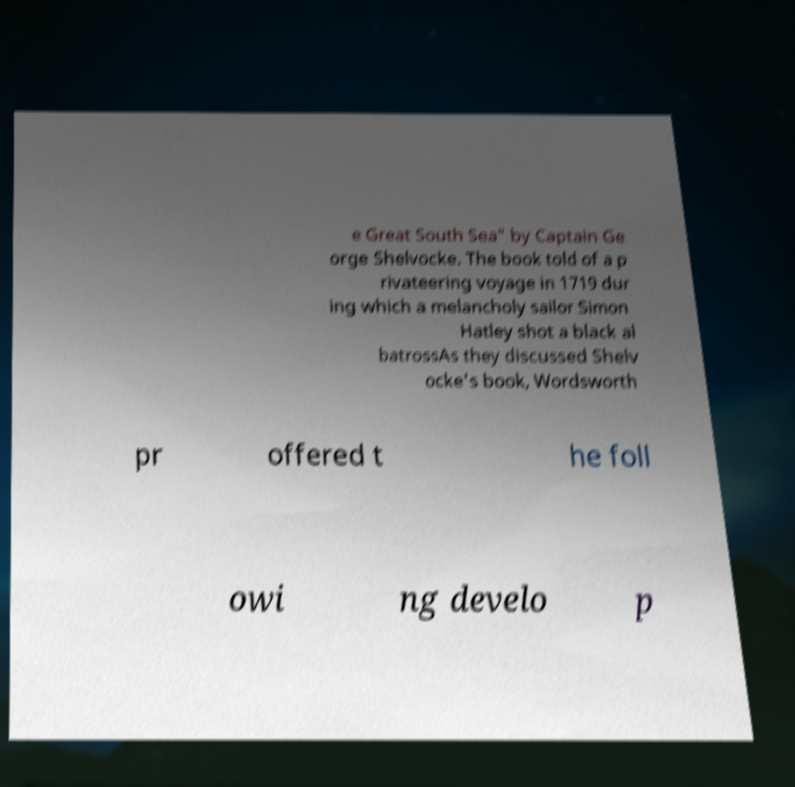Please read and relay the text visible in this image. What does it say? e Great South Sea" by Captain Ge orge Shelvocke. The book told of a p rivateering voyage in 1719 dur ing which a melancholy sailor Simon Hatley shot a black al batrossAs they discussed Shelv ocke's book, Wordsworth pr offered t he foll owi ng develo p 